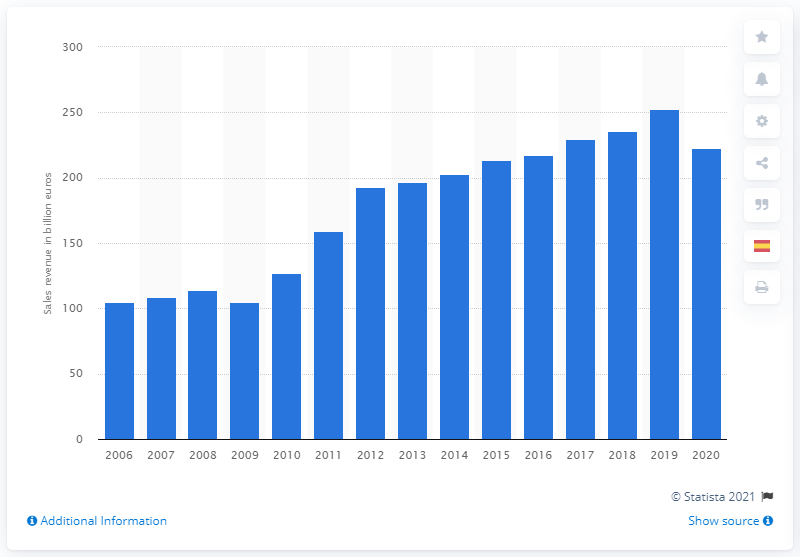List a handful of essential elements in this visual. In the 2020 fiscal year, Volkswagen's revenue was 222.88 billion. In the fiscal year of 2020, the revenue of Volkswagen Group decreased. 